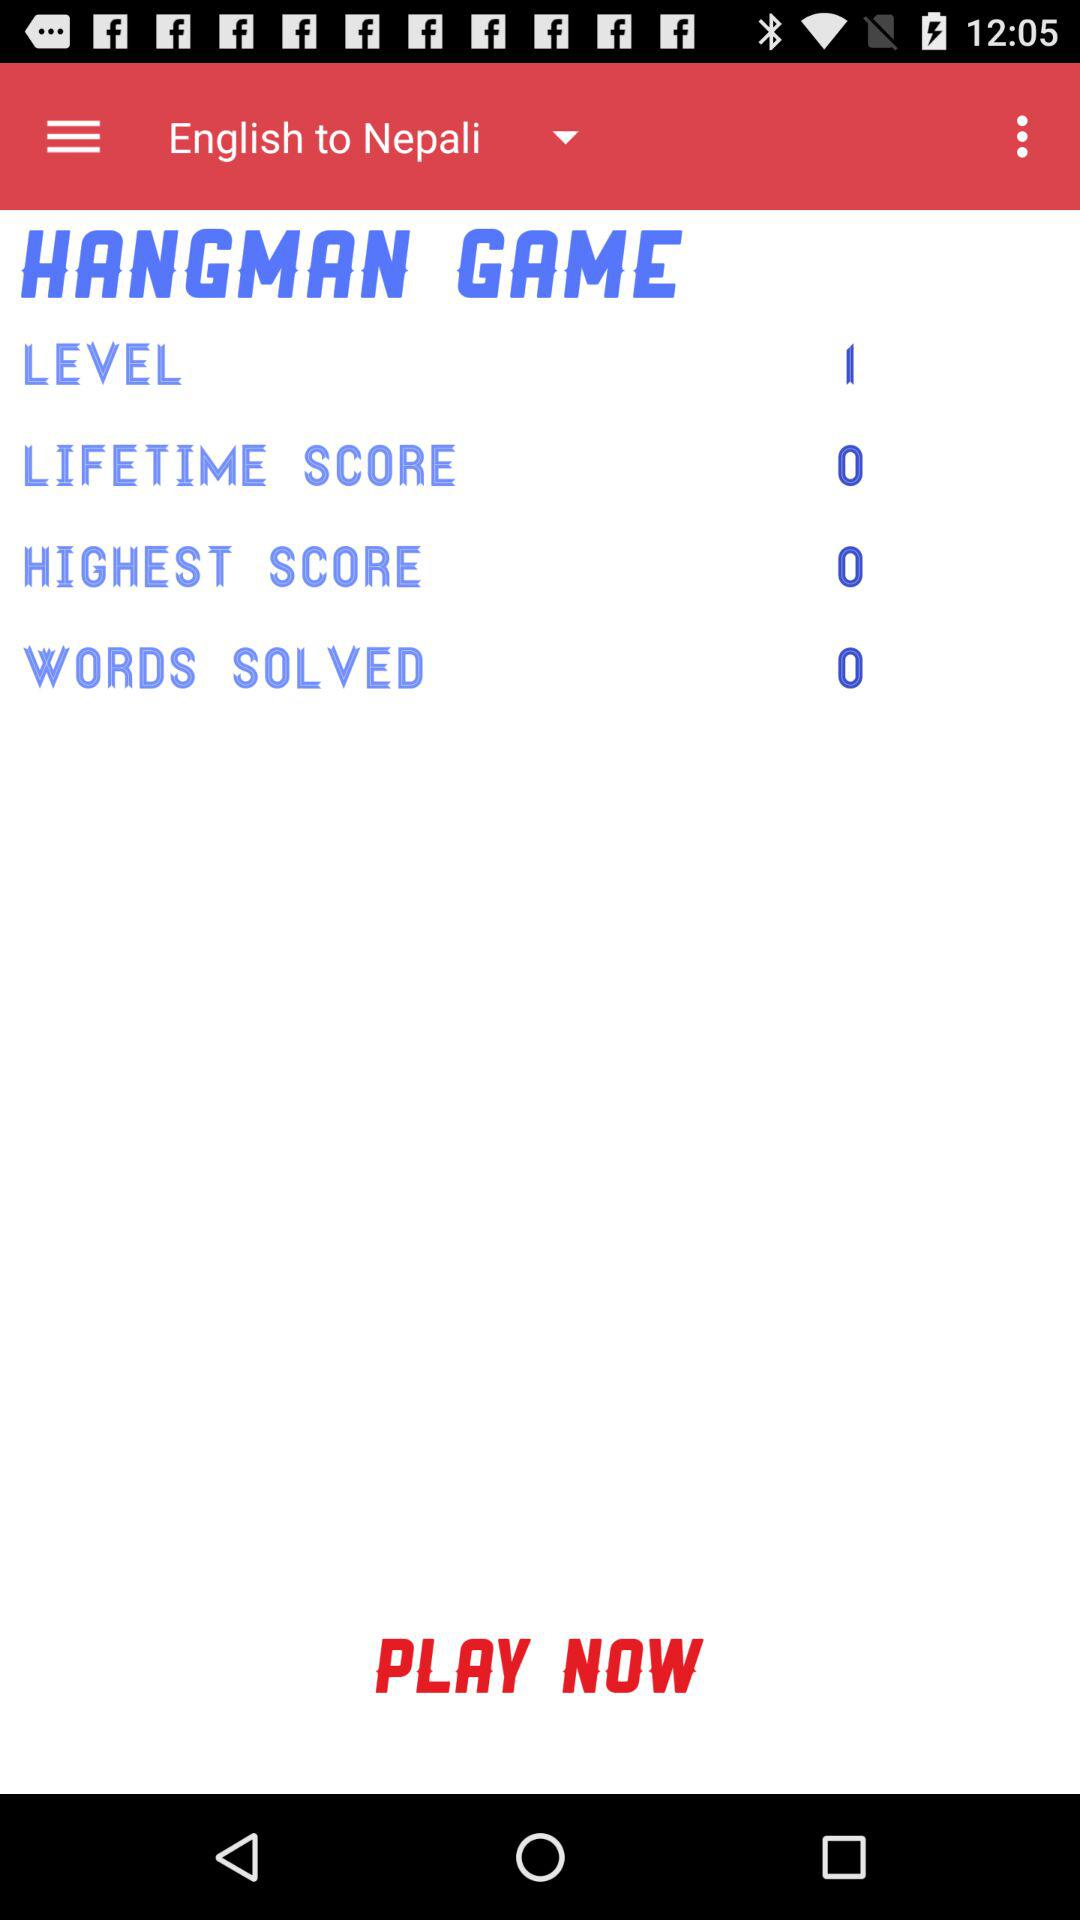What is the number of the level? The number of the level is 1. 